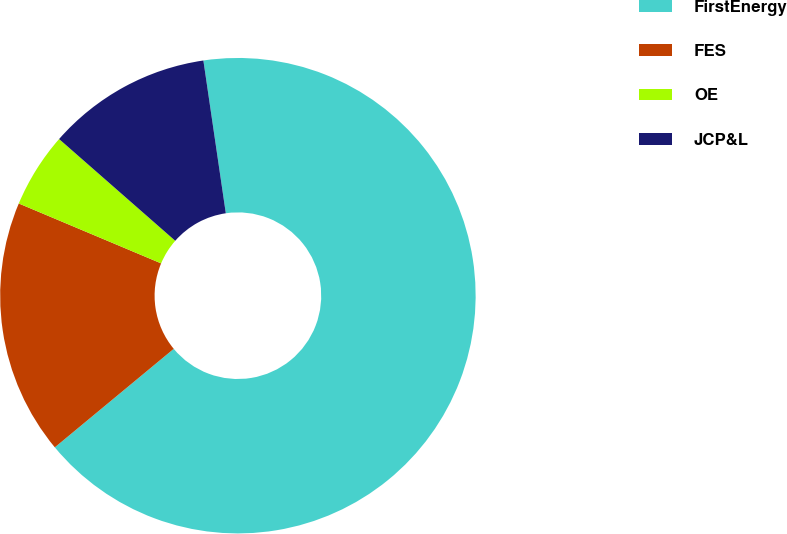Convert chart to OTSL. <chart><loc_0><loc_0><loc_500><loc_500><pie_chart><fcel>FirstEnergy<fcel>FES<fcel>OE<fcel>JCP&L<nl><fcel>66.31%<fcel>17.35%<fcel>5.11%<fcel>11.23%<nl></chart> 